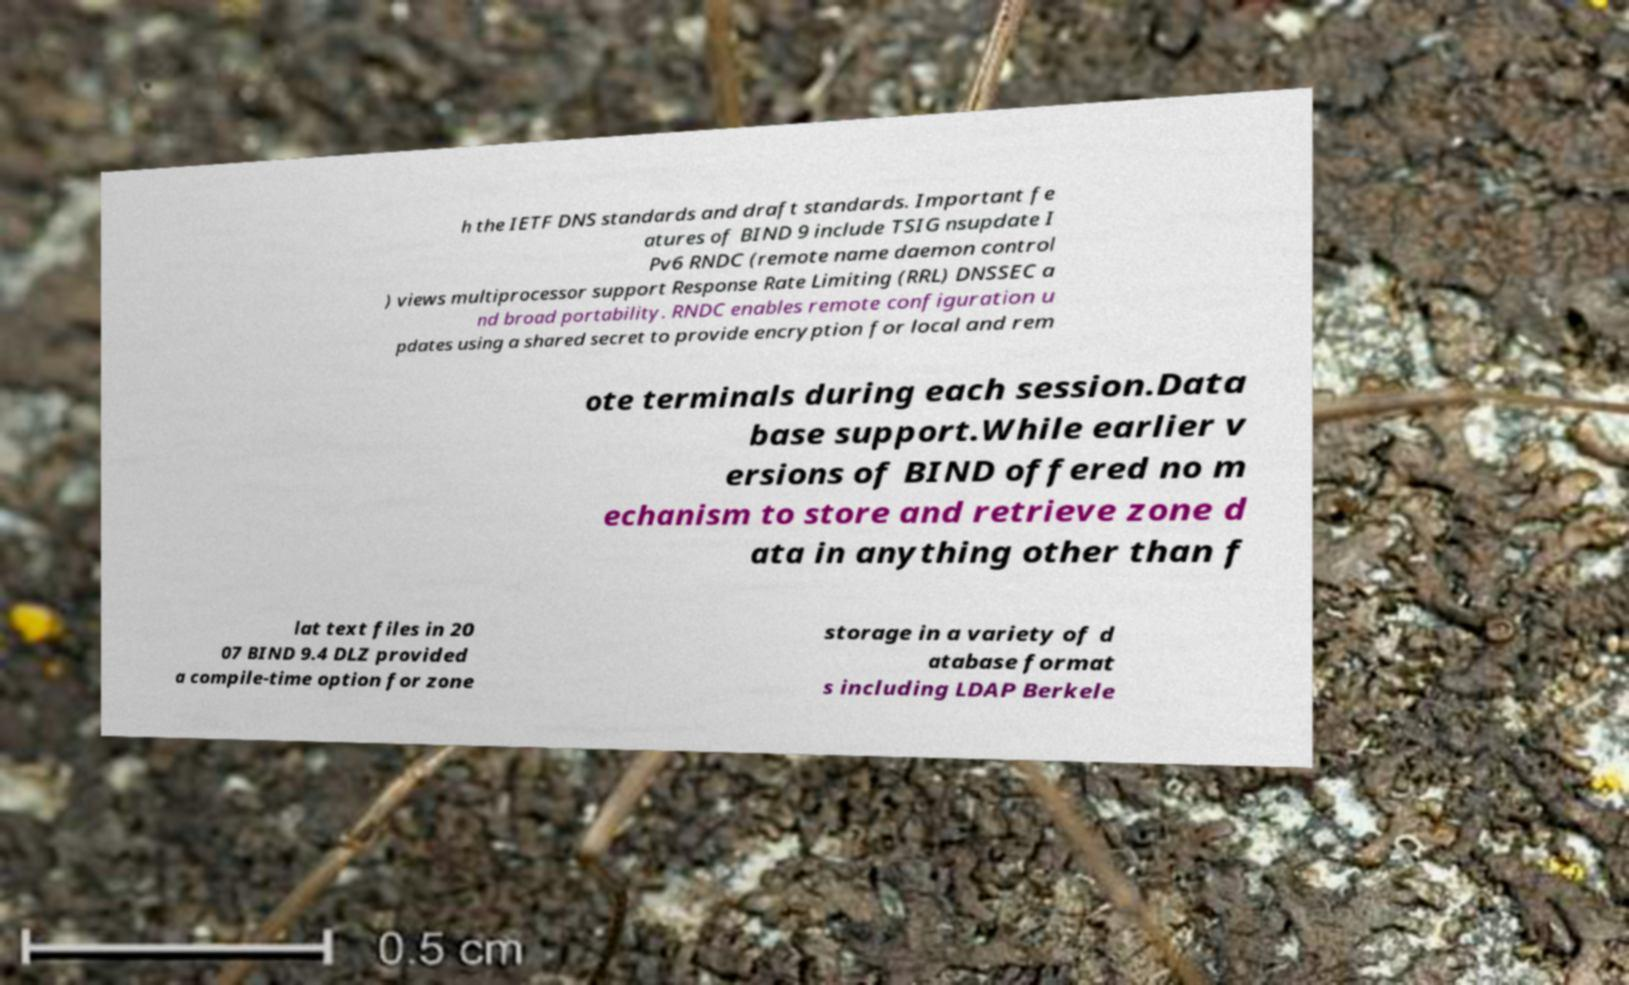Can you accurately transcribe the text from the provided image for me? h the IETF DNS standards and draft standards. Important fe atures of BIND 9 include TSIG nsupdate I Pv6 RNDC (remote name daemon control ) views multiprocessor support Response Rate Limiting (RRL) DNSSEC a nd broad portability. RNDC enables remote configuration u pdates using a shared secret to provide encryption for local and rem ote terminals during each session.Data base support.While earlier v ersions of BIND offered no m echanism to store and retrieve zone d ata in anything other than f lat text files in 20 07 BIND 9.4 DLZ provided a compile-time option for zone storage in a variety of d atabase format s including LDAP Berkele 